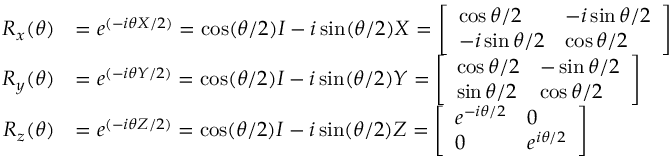Convert formula to latex. <formula><loc_0><loc_0><loc_500><loc_500>{ \begin{array} { r l } { R _ { x } ( \theta ) } & { = e ^ { ( - i \theta X / 2 ) } = \cos ( \theta / 2 ) I - i \sin ( \theta / 2 ) X = { \left [ \begin{array} { l l } { \cos \theta / 2 } & { - i \sin \theta / 2 } \\ { - i \sin \theta / 2 } & { \cos \theta / 2 } \end{array} \right ] } } \\ { R _ { y } ( \theta ) } & { = e ^ { ( - i \theta Y / 2 ) } = \cos ( \theta / 2 ) I - i \sin ( \theta / 2 ) Y = { \left [ \begin{array} { l l } { \cos \theta / 2 } & { - \sin \theta / 2 } \\ { \sin \theta / 2 } & { \cos \theta / 2 } \end{array} \right ] } } \\ { R _ { z } ( \theta ) } & { = e ^ { ( - i \theta Z / 2 ) } = \cos ( \theta / 2 ) I - i \sin ( \theta / 2 ) Z = { \left [ \begin{array} { l l } { e ^ { - i \theta / 2 } } & { 0 } \\ { 0 } & { e ^ { i \theta / 2 } } \end{array} \right ] } } \end{array} }</formula> 